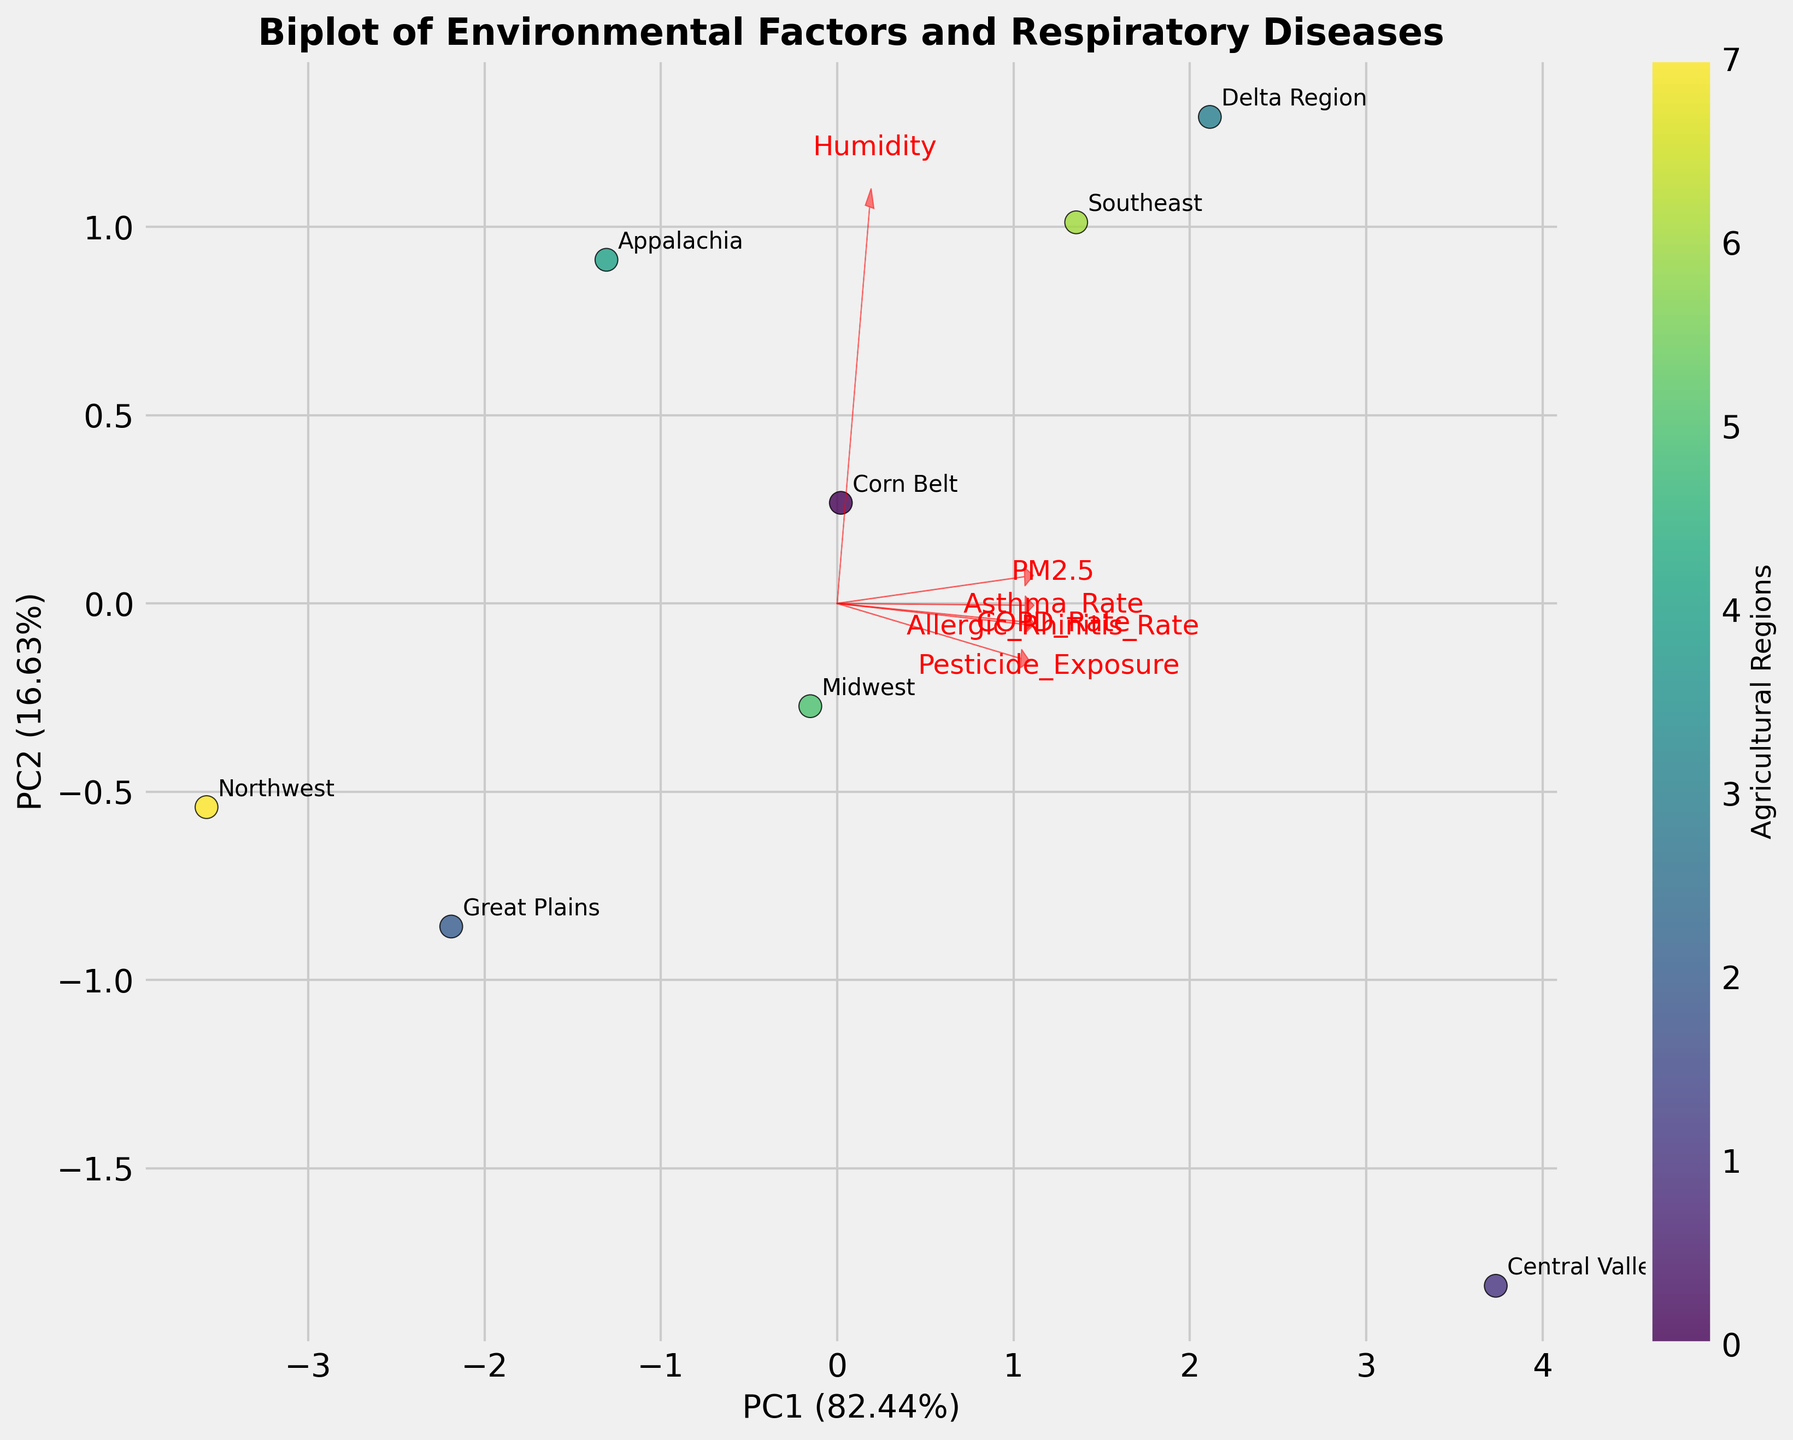How many agricultural regions are included in the biplot? The biplot shows a scatter with points labeled for each agricultural region. Counting these labels will give us the total number of regions.
Answer: 8 Which environmental factor or disease shows the longest vector in the biplot? The length of a vector in a biplot represents the importance or variance explained by that factor. By visually inspecting the lengths of the vectors, we can identify the longest.
Answer: Pesticide_Exposure What is the relationship between PM2.5 and Asthma Rate as shown in the biplot? In a biplot, the angle between vectors indicates the correlation between them. A small angle represents a high positive correlation, a 90-degree angle shows no correlation, and an angle close to 180 degrees represents negative correlation.
Answer: Positive correlation Which region appears most separated from the others based on the first two principal components? By looking at the distances among the points in the scatter plot of the biplot, the region farthest from the cluster of other regions is the most separated.
Answer: Central Valley How much of the total variance is explained by the first principal component (PC1)? The x-axis label of the biplot indicates the percentage of variance explained by the first principal component.
Answer: About 52.8% Which two agricultural regions are closest to each other in the biplot? By measuring the distance between points in the biplot, the regions with the smallest distance between them are the closest.
Answer: Midwest and Corn Belt Compare the correlation between Humidity and COPD Rate to the correlation between Pesticide Exposure and Asthma Rate. In a biplot, the angles between vectors show correlation. Closer or parallel vectors suggest a stronger correlation. Analyze the angles for these pairs.
Answer: Humidity and COPD Rate have a weaker correlation Does the vector for COPD Rate align more closely with Asthma Rate or PM2.5? By comparing the angles between the vectors representing COPD Rate and each of the other factors, we can determine which is more closely aligned.
Answer: Asthma Rate What can you infer about the relationship between Humidity and Allergic Rhinitis Rate? The direction and length of the vectors for Humidity and Allergic Rhinitis Rate indicate their relationship. Analyze the angle to infer the type of correlation.
Answer: Positive correlation Is the explained variance of the second principal component (PC2) higher or lower than 30%? The y-axis label of the biplot provides the percentage of variance explained by the second principal component. Compare this to 30%.
Answer: Higher 